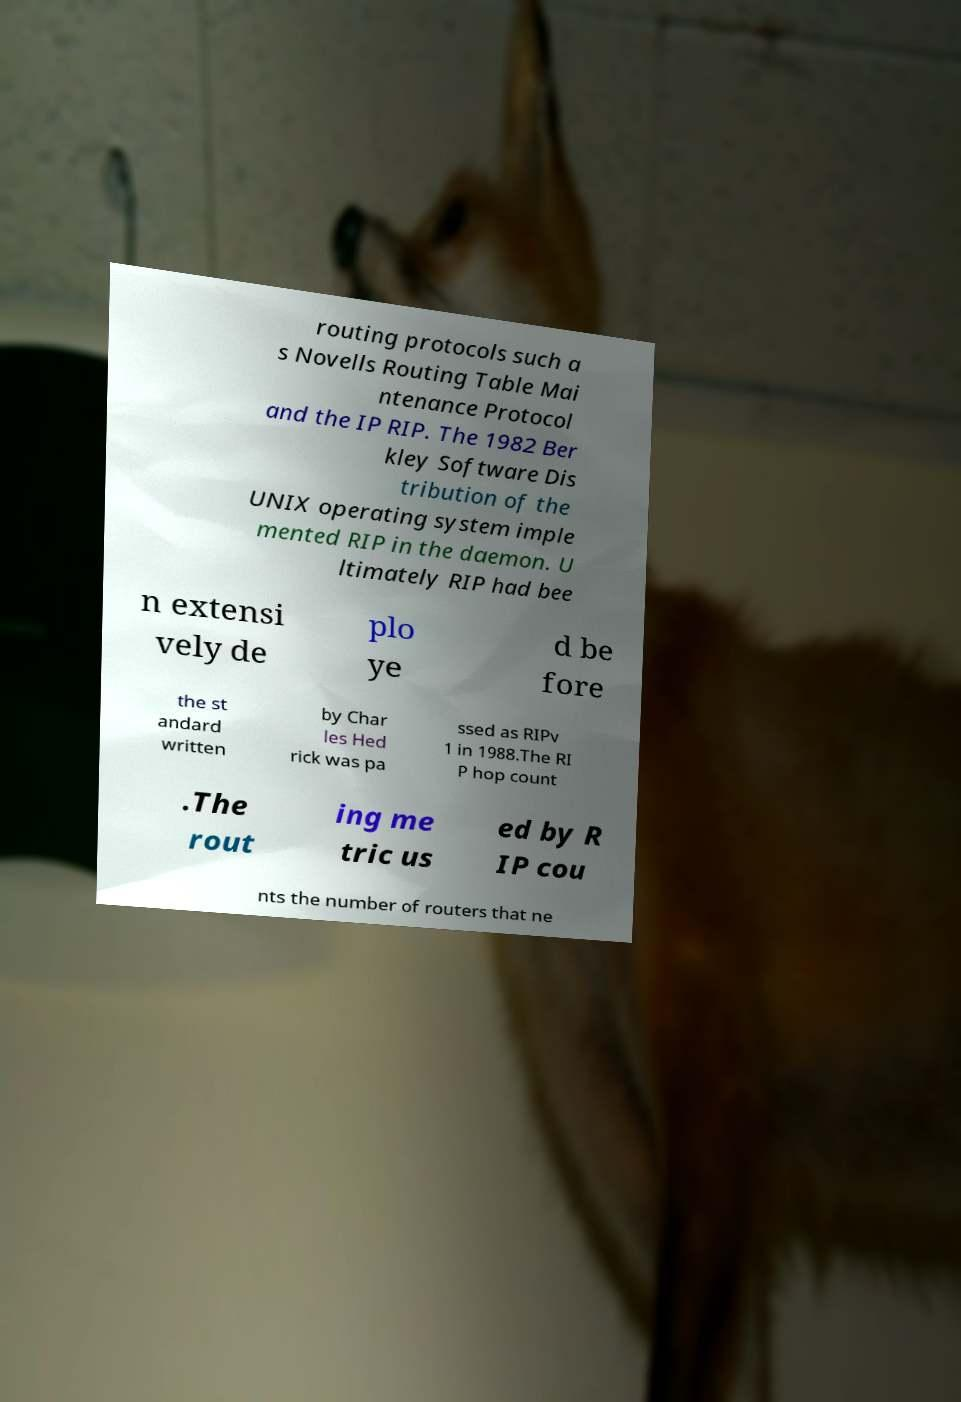For documentation purposes, I need the text within this image transcribed. Could you provide that? routing protocols such a s Novells Routing Table Mai ntenance Protocol and the IP RIP. The 1982 Ber kley Software Dis tribution of the UNIX operating system imple mented RIP in the daemon. U ltimately RIP had bee n extensi vely de plo ye d be fore the st andard written by Char les Hed rick was pa ssed as RIPv 1 in 1988.The RI P hop count .The rout ing me tric us ed by R IP cou nts the number of routers that ne 